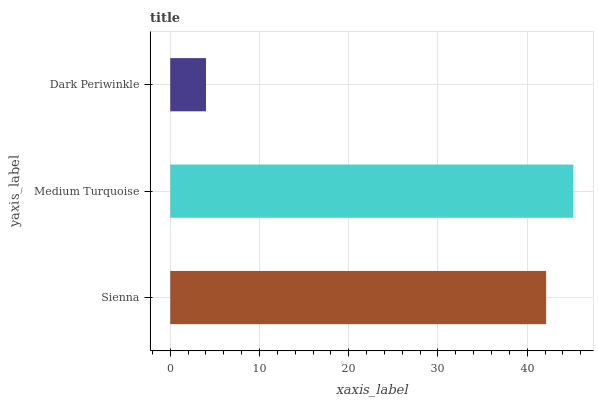Is Dark Periwinkle the minimum?
Answer yes or no. Yes. Is Medium Turquoise the maximum?
Answer yes or no. Yes. Is Medium Turquoise the minimum?
Answer yes or no. No. Is Dark Periwinkle the maximum?
Answer yes or no. No. Is Medium Turquoise greater than Dark Periwinkle?
Answer yes or no. Yes. Is Dark Periwinkle less than Medium Turquoise?
Answer yes or no. Yes. Is Dark Periwinkle greater than Medium Turquoise?
Answer yes or no. No. Is Medium Turquoise less than Dark Periwinkle?
Answer yes or no. No. Is Sienna the high median?
Answer yes or no. Yes. Is Sienna the low median?
Answer yes or no. Yes. Is Dark Periwinkle the high median?
Answer yes or no. No. Is Medium Turquoise the low median?
Answer yes or no. No. 